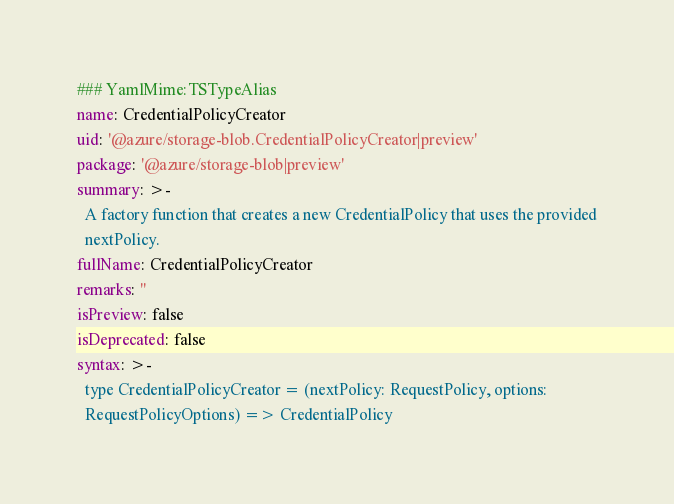<code> <loc_0><loc_0><loc_500><loc_500><_YAML_>### YamlMime:TSTypeAlias
name: CredentialPolicyCreator
uid: '@azure/storage-blob.CredentialPolicyCreator|preview'
package: '@azure/storage-blob|preview'
summary: >-
  A factory function that creates a new CredentialPolicy that uses the provided
  nextPolicy.
fullName: CredentialPolicyCreator
remarks: ''
isPreview: false
isDeprecated: false
syntax: >-
  type CredentialPolicyCreator = (nextPolicy: RequestPolicy, options:
  RequestPolicyOptions) => CredentialPolicy
</code> 